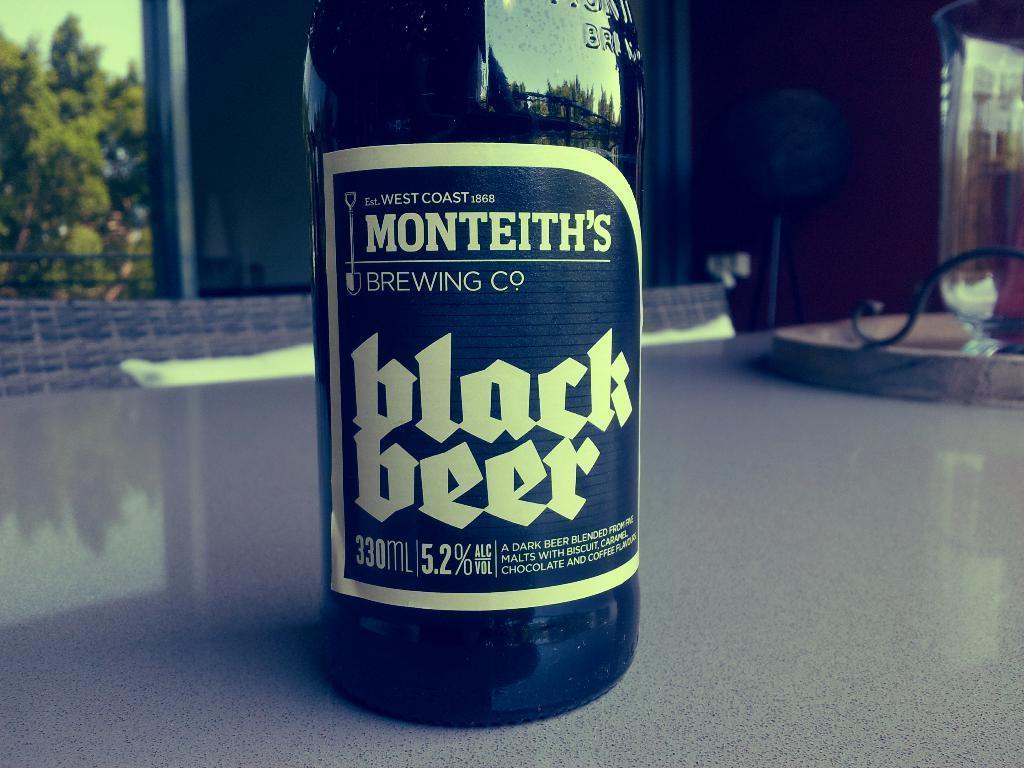Could you give a brief overview of what you see in this image? This is a beer bottle which is black in color with a label attached to the bottle. This bottle is placed on the table. At background I can see a tree. This looks like a wall and here is an object placed. 